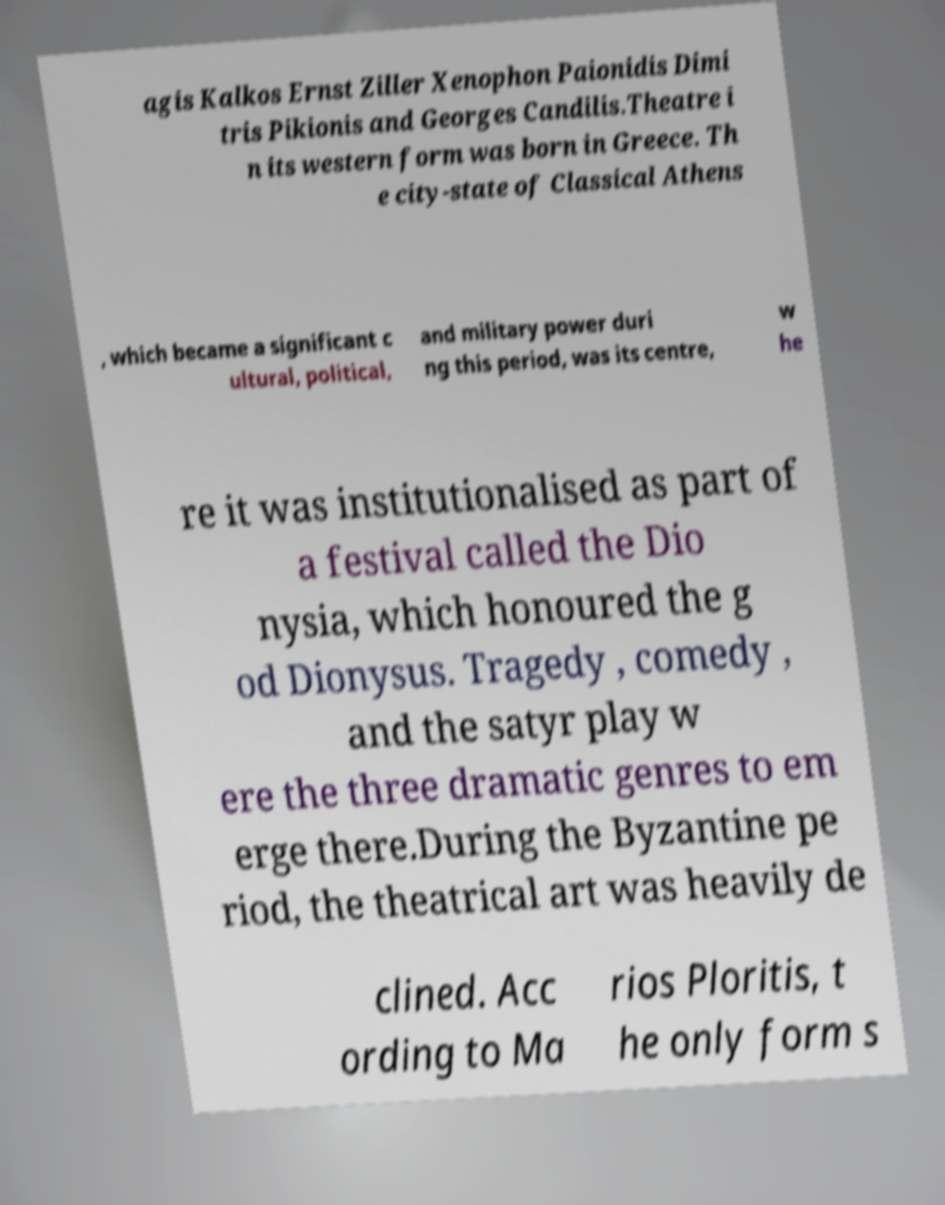Can you accurately transcribe the text from the provided image for me? agis Kalkos Ernst Ziller Xenophon Paionidis Dimi tris Pikionis and Georges Candilis.Theatre i n its western form was born in Greece. Th e city-state of Classical Athens , which became a significant c ultural, political, and military power duri ng this period, was its centre, w he re it was institutionalised as part of a festival called the Dio nysia, which honoured the g od Dionysus. Tragedy , comedy , and the satyr play w ere the three dramatic genres to em erge there.During the Byzantine pe riod, the theatrical art was heavily de clined. Acc ording to Ma rios Ploritis, t he only form s 